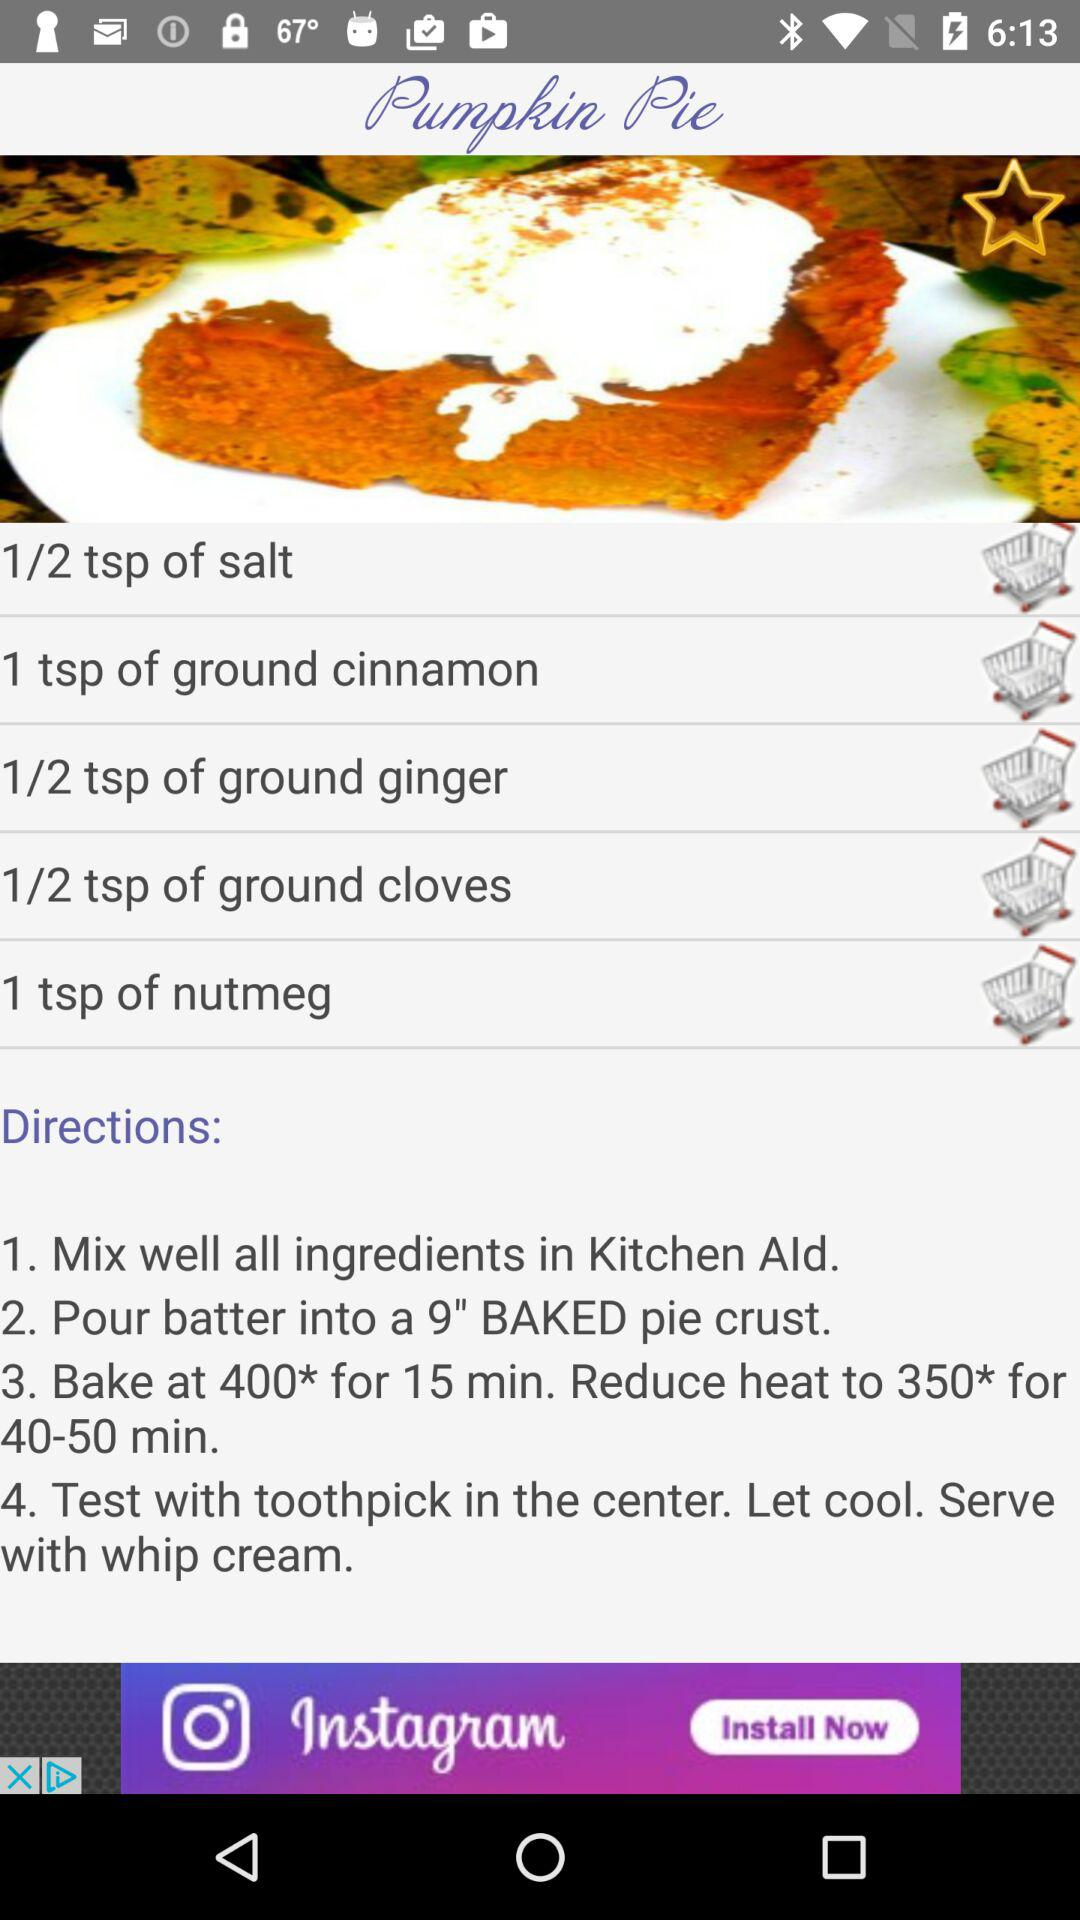What is the duration for pumpkin pie?
When the provided information is insufficient, respond with <no answer>. <no answer> 